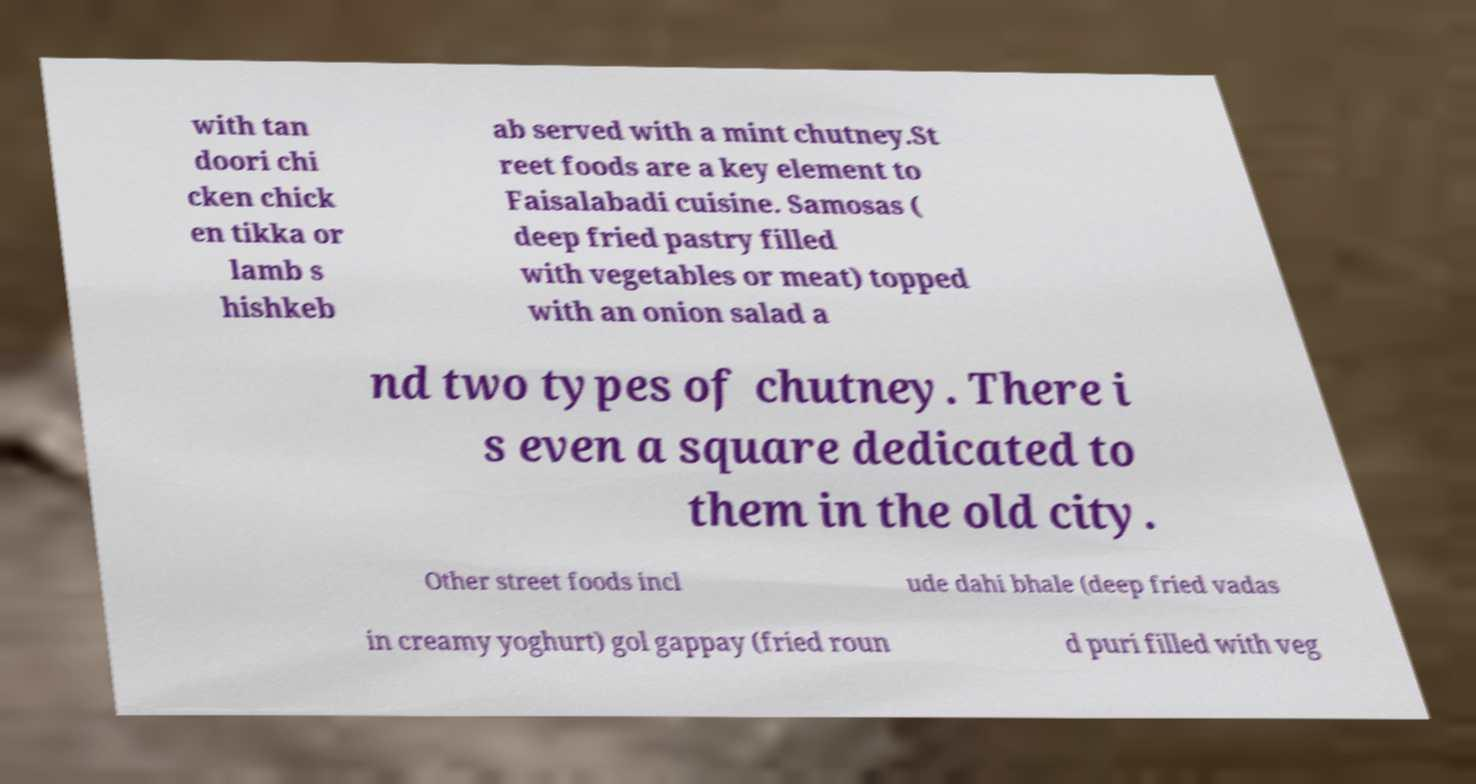There's text embedded in this image that I need extracted. Can you transcribe it verbatim? with tan doori chi cken chick en tikka or lamb s hishkeb ab served with a mint chutney.St reet foods are a key element to Faisalabadi cuisine. Samosas ( deep fried pastry filled with vegetables or meat) topped with an onion salad a nd two types of chutney. There i s even a square dedicated to them in the old city. Other street foods incl ude dahi bhale (deep fried vadas in creamy yoghurt) gol gappay (fried roun d puri filled with veg 